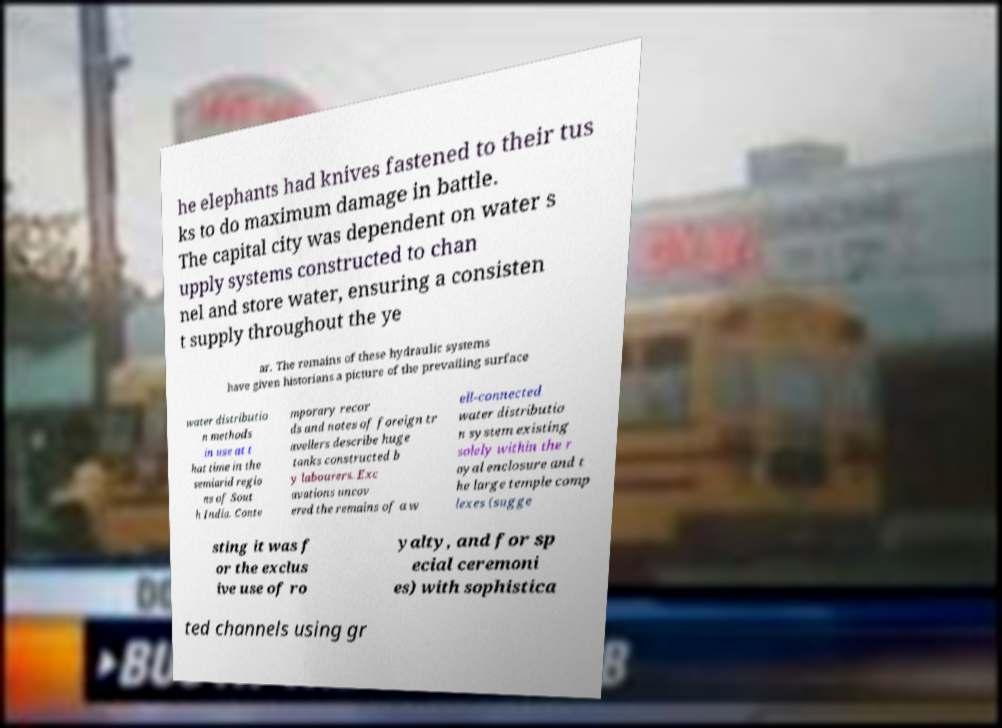Please read and relay the text visible in this image. What does it say? he elephants had knives fastened to their tus ks to do maximum damage in battle. The capital city was dependent on water s upply systems constructed to chan nel and store water, ensuring a consisten t supply throughout the ye ar. The remains of these hydraulic systems have given historians a picture of the prevailing surface water distributio n methods in use at t hat time in the semiarid regio ns of Sout h India. Conte mporary recor ds and notes of foreign tr avellers describe huge tanks constructed b y labourers. Exc avations uncov ered the remains of a w ell-connected water distributio n system existing solely within the r oyal enclosure and t he large temple comp lexes (sugge sting it was f or the exclus ive use of ro yalty, and for sp ecial ceremoni es) with sophistica ted channels using gr 